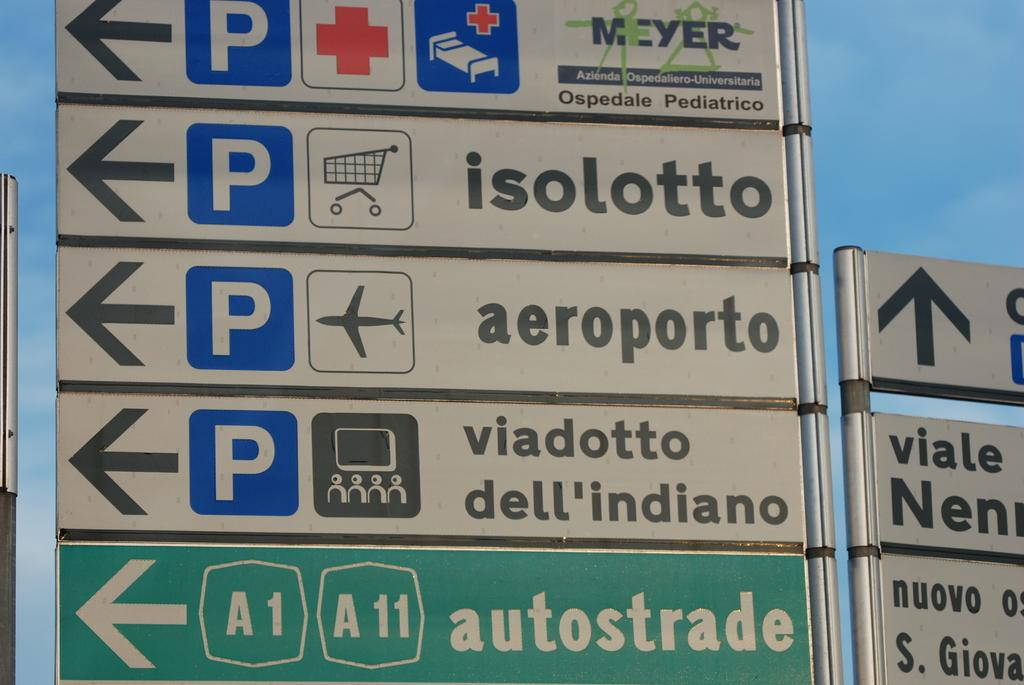<image>
Create a compact narrative representing the image presented. Street signs pointing to hospitals, stores, airports and entertainment areas. 